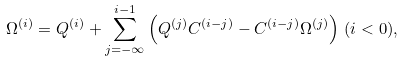<formula> <loc_0><loc_0><loc_500><loc_500>\Omega ^ { ( i ) } = Q ^ { ( i ) } + \sum _ { j = - \infty } ^ { i - 1 } \left ( Q ^ { ( j ) } C ^ { ( i - j ) } - C ^ { ( i - j ) } \Omega ^ { ( j ) } \right ) \, ( i < 0 ) ,</formula> 